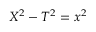Convert formula to latex. <formula><loc_0><loc_0><loc_500><loc_500>X ^ { 2 } - T ^ { 2 } = x ^ { 2 }</formula> 